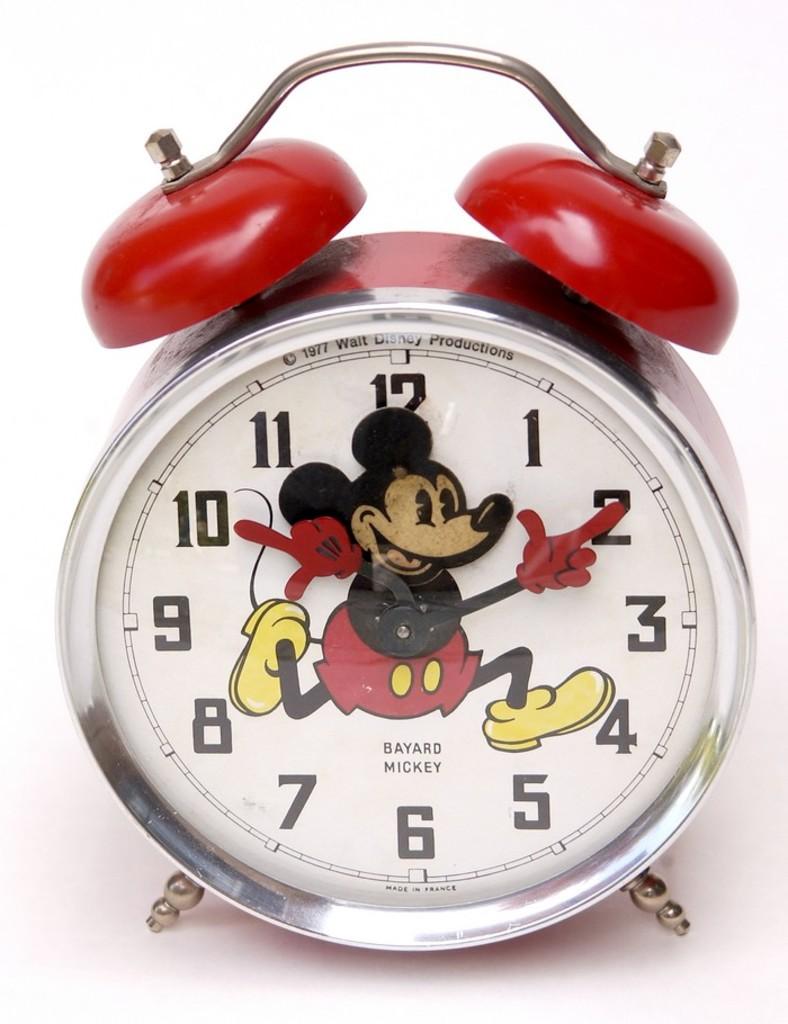What time is it?
Keep it short and to the point. 10:10. 